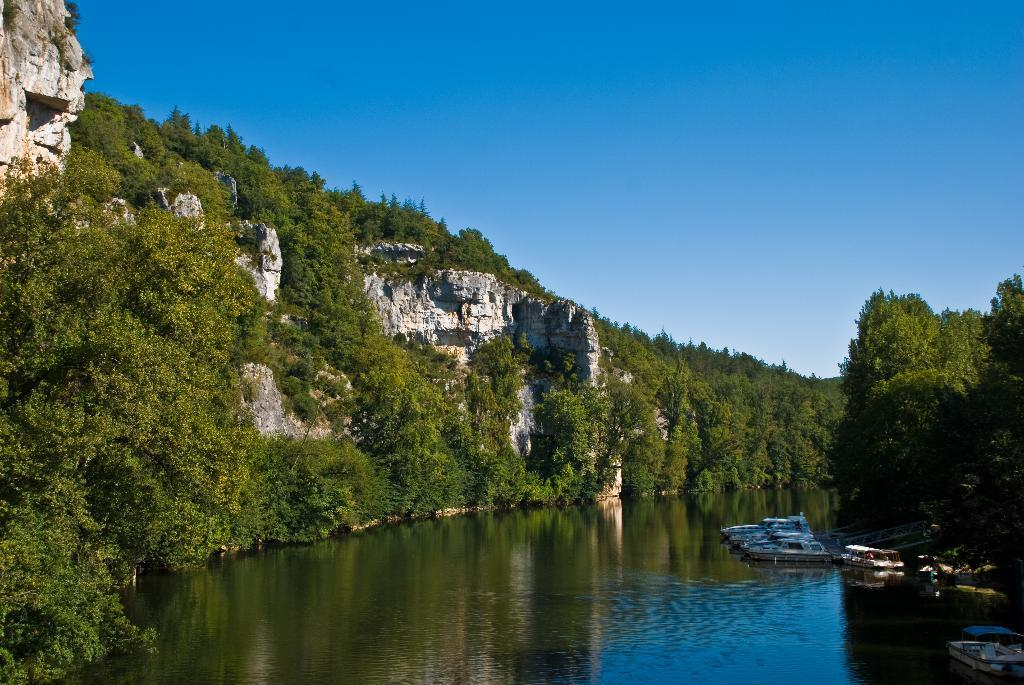What is on the water in the image? There are boats on the water in the image. What type of vegetation can be seen in the image? There are trees in the image. What geographical feature is visible in the image? There are mountains in the image. What is visible in the background of the image? The sky is visible in the background of the image. What type of sheet is being used by the farmer in the image? There is no farmer or sheet present in the image; it features boats on the water, trees, mountains, and the sky. 